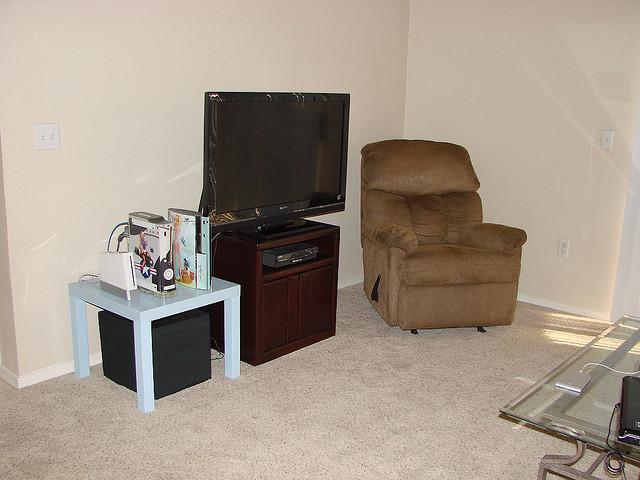What color is the chair?
Keep it brief. Brown. Is anyone sitting in the chair?
Concise answer only. No. What kind of television is in the photo?
Be succinct. Flat screen. Does this look like it's in a house or an apartment?
Quick response, please. Apartment. Is there a printer visible in the image?
Quick response, please. No. 